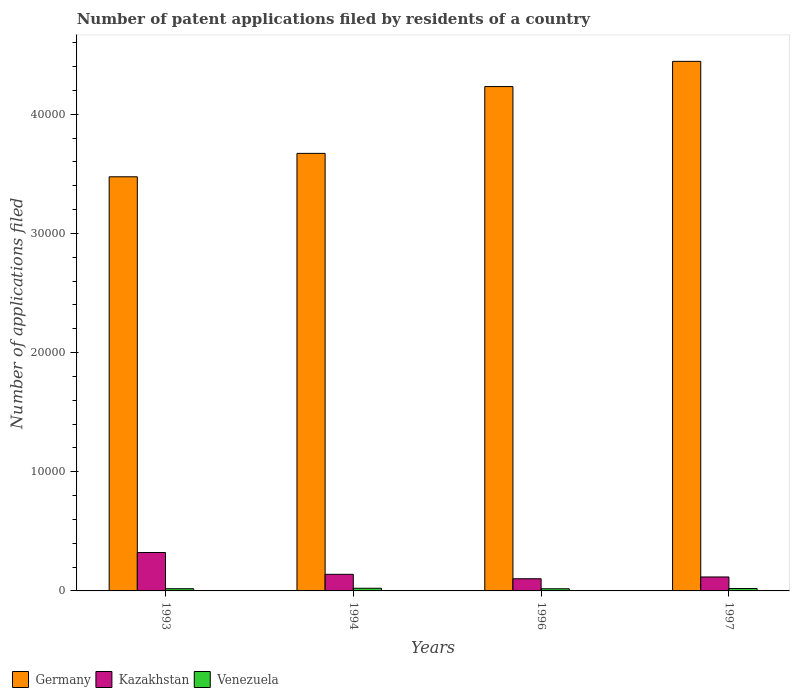Are the number of bars on each tick of the X-axis equal?
Provide a succinct answer. Yes. What is the number of applications filed in Kazakhstan in 1993?
Your answer should be very brief. 3223. Across all years, what is the maximum number of applications filed in Venezuela?
Your response must be concise. 224. Across all years, what is the minimum number of applications filed in Venezuela?
Offer a very short reply. 182. What is the total number of applications filed in Venezuela in the graph?
Your response must be concise. 793. What is the difference between the number of applications filed in Kazakhstan in 1996 and that in 1997?
Your response must be concise. -149. What is the difference between the number of applications filed in Venezuela in 1996 and the number of applications filed in Kazakhstan in 1994?
Provide a succinct answer. -1211. What is the average number of applications filed in Germany per year?
Make the answer very short. 3.96e+04. In the year 1997, what is the difference between the number of applications filed in Venezuela and number of applications filed in Kazakhstan?
Give a very brief answer. -970. What is the ratio of the number of applications filed in Venezuela in 1993 to that in 1996?
Provide a succinct answer. 1.02. Is the number of applications filed in Kazakhstan in 1996 less than that in 1997?
Provide a short and direct response. Yes. What is the difference between the highest and the second highest number of applications filed in Kazakhstan?
Offer a terse response. 1830. What is the difference between the highest and the lowest number of applications filed in Germany?
Make the answer very short. 9686. Is the sum of the number of applications filed in Kazakhstan in 1993 and 1994 greater than the maximum number of applications filed in Venezuela across all years?
Offer a very short reply. Yes. What does the 3rd bar from the left in 1996 represents?
Your answer should be compact. Venezuela. What does the 2nd bar from the right in 1994 represents?
Offer a very short reply. Kazakhstan. Is it the case that in every year, the sum of the number of applications filed in Venezuela and number of applications filed in Germany is greater than the number of applications filed in Kazakhstan?
Provide a short and direct response. Yes. Are all the bars in the graph horizontal?
Your answer should be very brief. No. How many years are there in the graph?
Provide a short and direct response. 4. Does the graph contain any zero values?
Give a very brief answer. No. Where does the legend appear in the graph?
Keep it short and to the point. Bottom left. What is the title of the graph?
Your answer should be very brief. Number of patent applications filed by residents of a country. What is the label or title of the X-axis?
Make the answer very short. Years. What is the label or title of the Y-axis?
Offer a very short reply. Number of applications filed. What is the Number of applications filed in Germany in 1993?
Provide a short and direct response. 3.48e+04. What is the Number of applications filed in Kazakhstan in 1993?
Make the answer very short. 3223. What is the Number of applications filed in Venezuela in 1993?
Make the answer very short. 186. What is the Number of applications filed of Germany in 1994?
Ensure brevity in your answer.  3.67e+04. What is the Number of applications filed in Kazakhstan in 1994?
Offer a very short reply. 1393. What is the Number of applications filed in Venezuela in 1994?
Offer a terse response. 224. What is the Number of applications filed of Germany in 1996?
Keep it short and to the point. 4.23e+04. What is the Number of applications filed in Kazakhstan in 1996?
Offer a very short reply. 1022. What is the Number of applications filed in Venezuela in 1996?
Your answer should be very brief. 182. What is the Number of applications filed of Germany in 1997?
Give a very brief answer. 4.44e+04. What is the Number of applications filed of Kazakhstan in 1997?
Your answer should be compact. 1171. What is the Number of applications filed of Venezuela in 1997?
Offer a terse response. 201. Across all years, what is the maximum Number of applications filed of Germany?
Provide a succinct answer. 4.44e+04. Across all years, what is the maximum Number of applications filed in Kazakhstan?
Your answer should be compact. 3223. Across all years, what is the maximum Number of applications filed in Venezuela?
Provide a succinct answer. 224. Across all years, what is the minimum Number of applications filed of Germany?
Give a very brief answer. 3.48e+04. Across all years, what is the minimum Number of applications filed of Kazakhstan?
Keep it short and to the point. 1022. Across all years, what is the minimum Number of applications filed of Venezuela?
Your answer should be very brief. 182. What is the total Number of applications filed of Germany in the graph?
Offer a very short reply. 1.58e+05. What is the total Number of applications filed in Kazakhstan in the graph?
Your response must be concise. 6809. What is the total Number of applications filed of Venezuela in the graph?
Give a very brief answer. 793. What is the difference between the Number of applications filed of Germany in 1993 and that in 1994?
Keep it short and to the point. -1963. What is the difference between the Number of applications filed in Kazakhstan in 1993 and that in 1994?
Give a very brief answer. 1830. What is the difference between the Number of applications filed in Venezuela in 1993 and that in 1994?
Provide a succinct answer. -38. What is the difference between the Number of applications filed in Germany in 1993 and that in 1996?
Offer a terse response. -7570. What is the difference between the Number of applications filed of Kazakhstan in 1993 and that in 1996?
Make the answer very short. 2201. What is the difference between the Number of applications filed in Venezuela in 1993 and that in 1996?
Your answer should be compact. 4. What is the difference between the Number of applications filed of Germany in 1993 and that in 1997?
Ensure brevity in your answer.  -9686. What is the difference between the Number of applications filed in Kazakhstan in 1993 and that in 1997?
Ensure brevity in your answer.  2052. What is the difference between the Number of applications filed in Venezuela in 1993 and that in 1997?
Make the answer very short. -15. What is the difference between the Number of applications filed in Germany in 1994 and that in 1996?
Ensure brevity in your answer.  -5607. What is the difference between the Number of applications filed in Kazakhstan in 1994 and that in 1996?
Make the answer very short. 371. What is the difference between the Number of applications filed in Germany in 1994 and that in 1997?
Provide a short and direct response. -7723. What is the difference between the Number of applications filed in Kazakhstan in 1994 and that in 1997?
Give a very brief answer. 222. What is the difference between the Number of applications filed of Germany in 1996 and that in 1997?
Your answer should be very brief. -2116. What is the difference between the Number of applications filed of Kazakhstan in 1996 and that in 1997?
Ensure brevity in your answer.  -149. What is the difference between the Number of applications filed of Venezuela in 1996 and that in 1997?
Offer a very short reply. -19. What is the difference between the Number of applications filed of Germany in 1993 and the Number of applications filed of Kazakhstan in 1994?
Offer a very short reply. 3.34e+04. What is the difference between the Number of applications filed of Germany in 1993 and the Number of applications filed of Venezuela in 1994?
Make the answer very short. 3.45e+04. What is the difference between the Number of applications filed in Kazakhstan in 1993 and the Number of applications filed in Venezuela in 1994?
Your response must be concise. 2999. What is the difference between the Number of applications filed in Germany in 1993 and the Number of applications filed in Kazakhstan in 1996?
Provide a short and direct response. 3.37e+04. What is the difference between the Number of applications filed of Germany in 1993 and the Number of applications filed of Venezuela in 1996?
Your response must be concise. 3.46e+04. What is the difference between the Number of applications filed of Kazakhstan in 1993 and the Number of applications filed of Venezuela in 1996?
Your answer should be very brief. 3041. What is the difference between the Number of applications filed in Germany in 1993 and the Number of applications filed in Kazakhstan in 1997?
Your answer should be very brief. 3.36e+04. What is the difference between the Number of applications filed in Germany in 1993 and the Number of applications filed in Venezuela in 1997?
Your answer should be very brief. 3.46e+04. What is the difference between the Number of applications filed in Kazakhstan in 1993 and the Number of applications filed in Venezuela in 1997?
Your answer should be very brief. 3022. What is the difference between the Number of applications filed of Germany in 1994 and the Number of applications filed of Kazakhstan in 1996?
Provide a short and direct response. 3.57e+04. What is the difference between the Number of applications filed of Germany in 1994 and the Number of applications filed of Venezuela in 1996?
Provide a short and direct response. 3.65e+04. What is the difference between the Number of applications filed of Kazakhstan in 1994 and the Number of applications filed of Venezuela in 1996?
Offer a very short reply. 1211. What is the difference between the Number of applications filed in Germany in 1994 and the Number of applications filed in Kazakhstan in 1997?
Offer a very short reply. 3.55e+04. What is the difference between the Number of applications filed of Germany in 1994 and the Number of applications filed of Venezuela in 1997?
Offer a terse response. 3.65e+04. What is the difference between the Number of applications filed of Kazakhstan in 1994 and the Number of applications filed of Venezuela in 1997?
Provide a short and direct response. 1192. What is the difference between the Number of applications filed in Germany in 1996 and the Number of applications filed in Kazakhstan in 1997?
Provide a succinct answer. 4.12e+04. What is the difference between the Number of applications filed of Germany in 1996 and the Number of applications filed of Venezuela in 1997?
Your response must be concise. 4.21e+04. What is the difference between the Number of applications filed of Kazakhstan in 1996 and the Number of applications filed of Venezuela in 1997?
Provide a succinct answer. 821. What is the average Number of applications filed in Germany per year?
Your answer should be compact. 3.96e+04. What is the average Number of applications filed of Kazakhstan per year?
Provide a short and direct response. 1702.25. What is the average Number of applications filed in Venezuela per year?
Your answer should be compact. 198.25. In the year 1993, what is the difference between the Number of applications filed in Germany and Number of applications filed in Kazakhstan?
Your answer should be compact. 3.15e+04. In the year 1993, what is the difference between the Number of applications filed in Germany and Number of applications filed in Venezuela?
Provide a succinct answer. 3.46e+04. In the year 1993, what is the difference between the Number of applications filed of Kazakhstan and Number of applications filed of Venezuela?
Make the answer very short. 3037. In the year 1994, what is the difference between the Number of applications filed in Germany and Number of applications filed in Kazakhstan?
Your response must be concise. 3.53e+04. In the year 1994, what is the difference between the Number of applications filed of Germany and Number of applications filed of Venezuela?
Provide a short and direct response. 3.65e+04. In the year 1994, what is the difference between the Number of applications filed of Kazakhstan and Number of applications filed of Venezuela?
Offer a terse response. 1169. In the year 1996, what is the difference between the Number of applications filed in Germany and Number of applications filed in Kazakhstan?
Your answer should be very brief. 4.13e+04. In the year 1996, what is the difference between the Number of applications filed of Germany and Number of applications filed of Venezuela?
Make the answer very short. 4.21e+04. In the year 1996, what is the difference between the Number of applications filed in Kazakhstan and Number of applications filed in Venezuela?
Keep it short and to the point. 840. In the year 1997, what is the difference between the Number of applications filed of Germany and Number of applications filed of Kazakhstan?
Offer a very short reply. 4.33e+04. In the year 1997, what is the difference between the Number of applications filed in Germany and Number of applications filed in Venezuela?
Keep it short and to the point. 4.42e+04. In the year 1997, what is the difference between the Number of applications filed in Kazakhstan and Number of applications filed in Venezuela?
Make the answer very short. 970. What is the ratio of the Number of applications filed in Germany in 1993 to that in 1994?
Keep it short and to the point. 0.95. What is the ratio of the Number of applications filed of Kazakhstan in 1993 to that in 1994?
Keep it short and to the point. 2.31. What is the ratio of the Number of applications filed in Venezuela in 1993 to that in 1994?
Your answer should be compact. 0.83. What is the ratio of the Number of applications filed of Germany in 1993 to that in 1996?
Make the answer very short. 0.82. What is the ratio of the Number of applications filed in Kazakhstan in 1993 to that in 1996?
Keep it short and to the point. 3.15. What is the ratio of the Number of applications filed in Germany in 1993 to that in 1997?
Offer a very short reply. 0.78. What is the ratio of the Number of applications filed of Kazakhstan in 1993 to that in 1997?
Make the answer very short. 2.75. What is the ratio of the Number of applications filed of Venezuela in 1993 to that in 1997?
Give a very brief answer. 0.93. What is the ratio of the Number of applications filed of Germany in 1994 to that in 1996?
Your answer should be compact. 0.87. What is the ratio of the Number of applications filed in Kazakhstan in 1994 to that in 1996?
Your response must be concise. 1.36. What is the ratio of the Number of applications filed in Venezuela in 1994 to that in 1996?
Your answer should be compact. 1.23. What is the ratio of the Number of applications filed in Germany in 1994 to that in 1997?
Your answer should be very brief. 0.83. What is the ratio of the Number of applications filed of Kazakhstan in 1994 to that in 1997?
Provide a short and direct response. 1.19. What is the ratio of the Number of applications filed in Venezuela in 1994 to that in 1997?
Your answer should be very brief. 1.11. What is the ratio of the Number of applications filed of Kazakhstan in 1996 to that in 1997?
Offer a terse response. 0.87. What is the ratio of the Number of applications filed in Venezuela in 1996 to that in 1997?
Your answer should be compact. 0.91. What is the difference between the highest and the second highest Number of applications filed in Germany?
Provide a short and direct response. 2116. What is the difference between the highest and the second highest Number of applications filed in Kazakhstan?
Make the answer very short. 1830. What is the difference between the highest and the second highest Number of applications filed in Venezuela?
Offer a terse response. 23. What is the difference between the highest and the lowest Number of applications filed of Germany?
Make the answer very short. 9686. What is the difference between the highest and the lowest Number of applications filed of Kazakhstan?
Provide a short and direct response. 2201. What is the difference between the highest and the lowest Number of applications filed in Venezuela?
Provide a succinct answer. 42. 